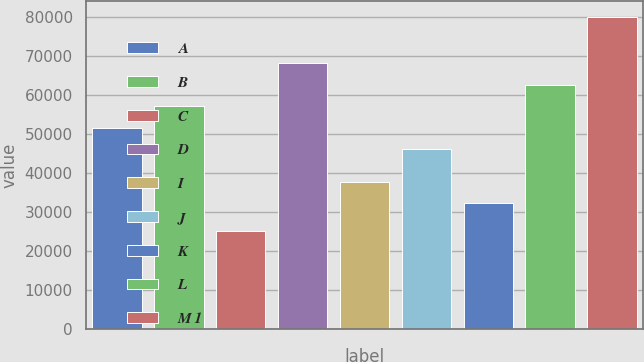Convert chart to OTSL. <chart><loc_0><loc_0><loc_500><loc_500><bar_chart><fcel>A<fcel>B<fcel>C<fcel>D<fcel>I<fcel>J<fcel>K<fcel>L<fcel>M 1<nl><fcel>51500<fcel>57000<fcel>25000<fcel>68000<fcel>37700<fcel>46000<fcel>32200<fcel>62500<fcel>80000<nl></chart> 